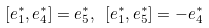<formula> <loc_0><loc_0><loc_500><loc_500>[ e _ { 1 } ^ { * } , e _ { 4 } ^ { * } ] = e _ { 5 } ^ { * } , \ [ e _ { 1 } ^ { * } , e _ { 5 } ^ { * } ] = - e _ { 4 } ^ { * }</formula> 